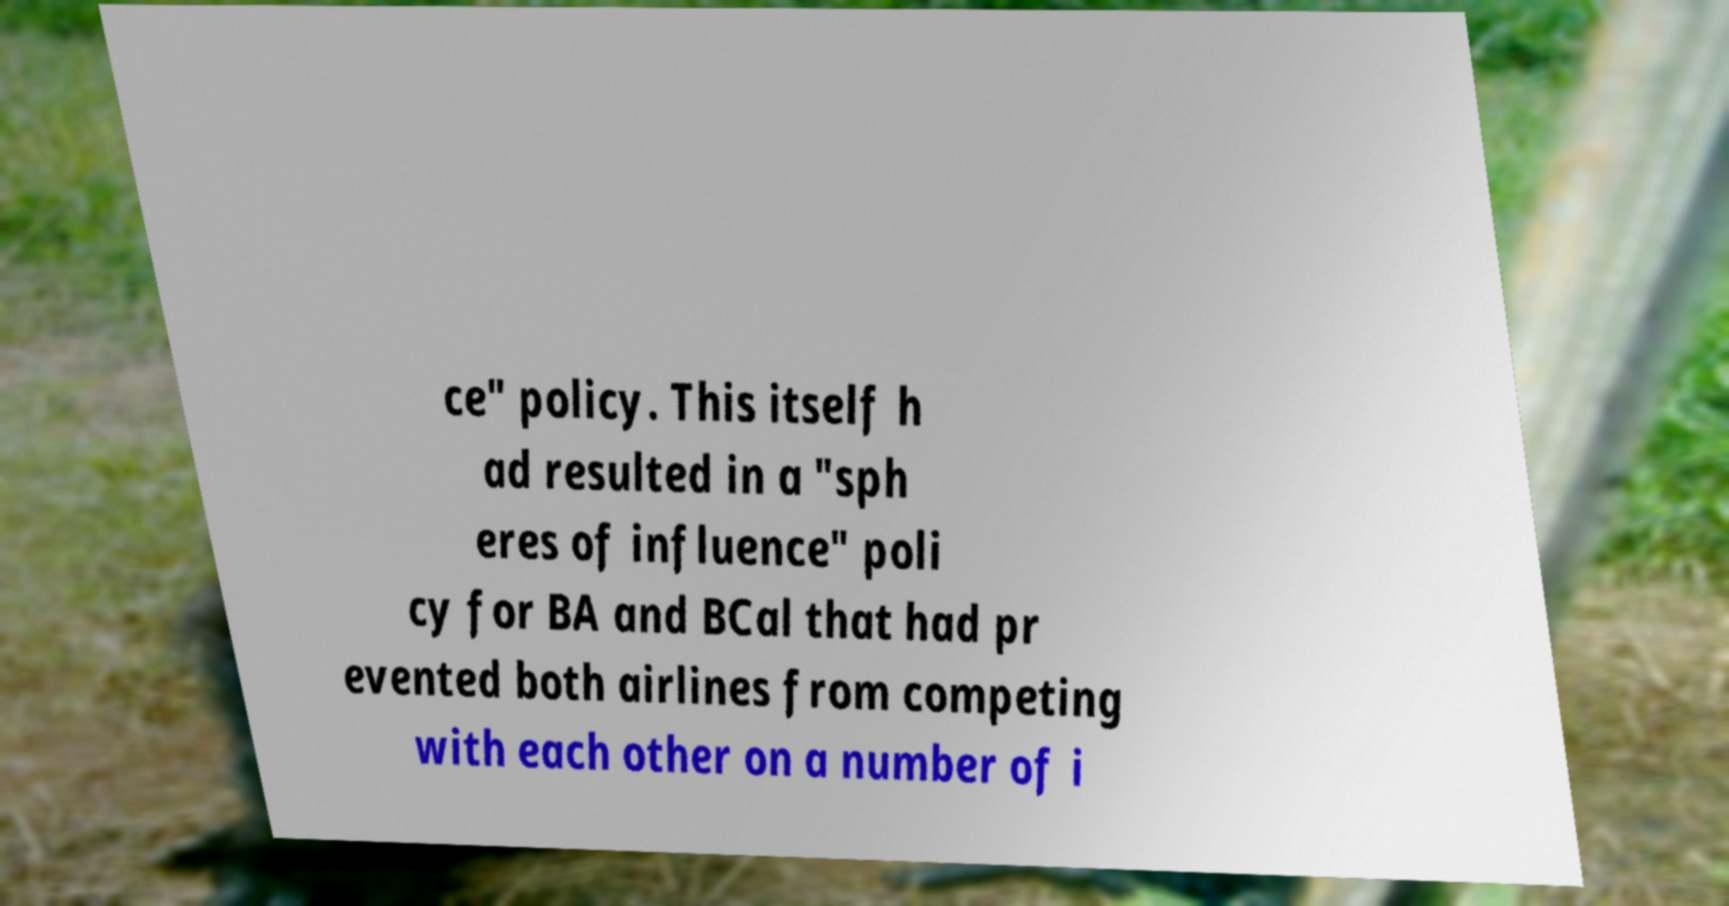Could you extract and type out the text from this image? ce" policy. This itself h ad resulted in a "sph eres of influence" poli cy for BA and BCal that had pr evented both airlines from competing with each other on a number of i 